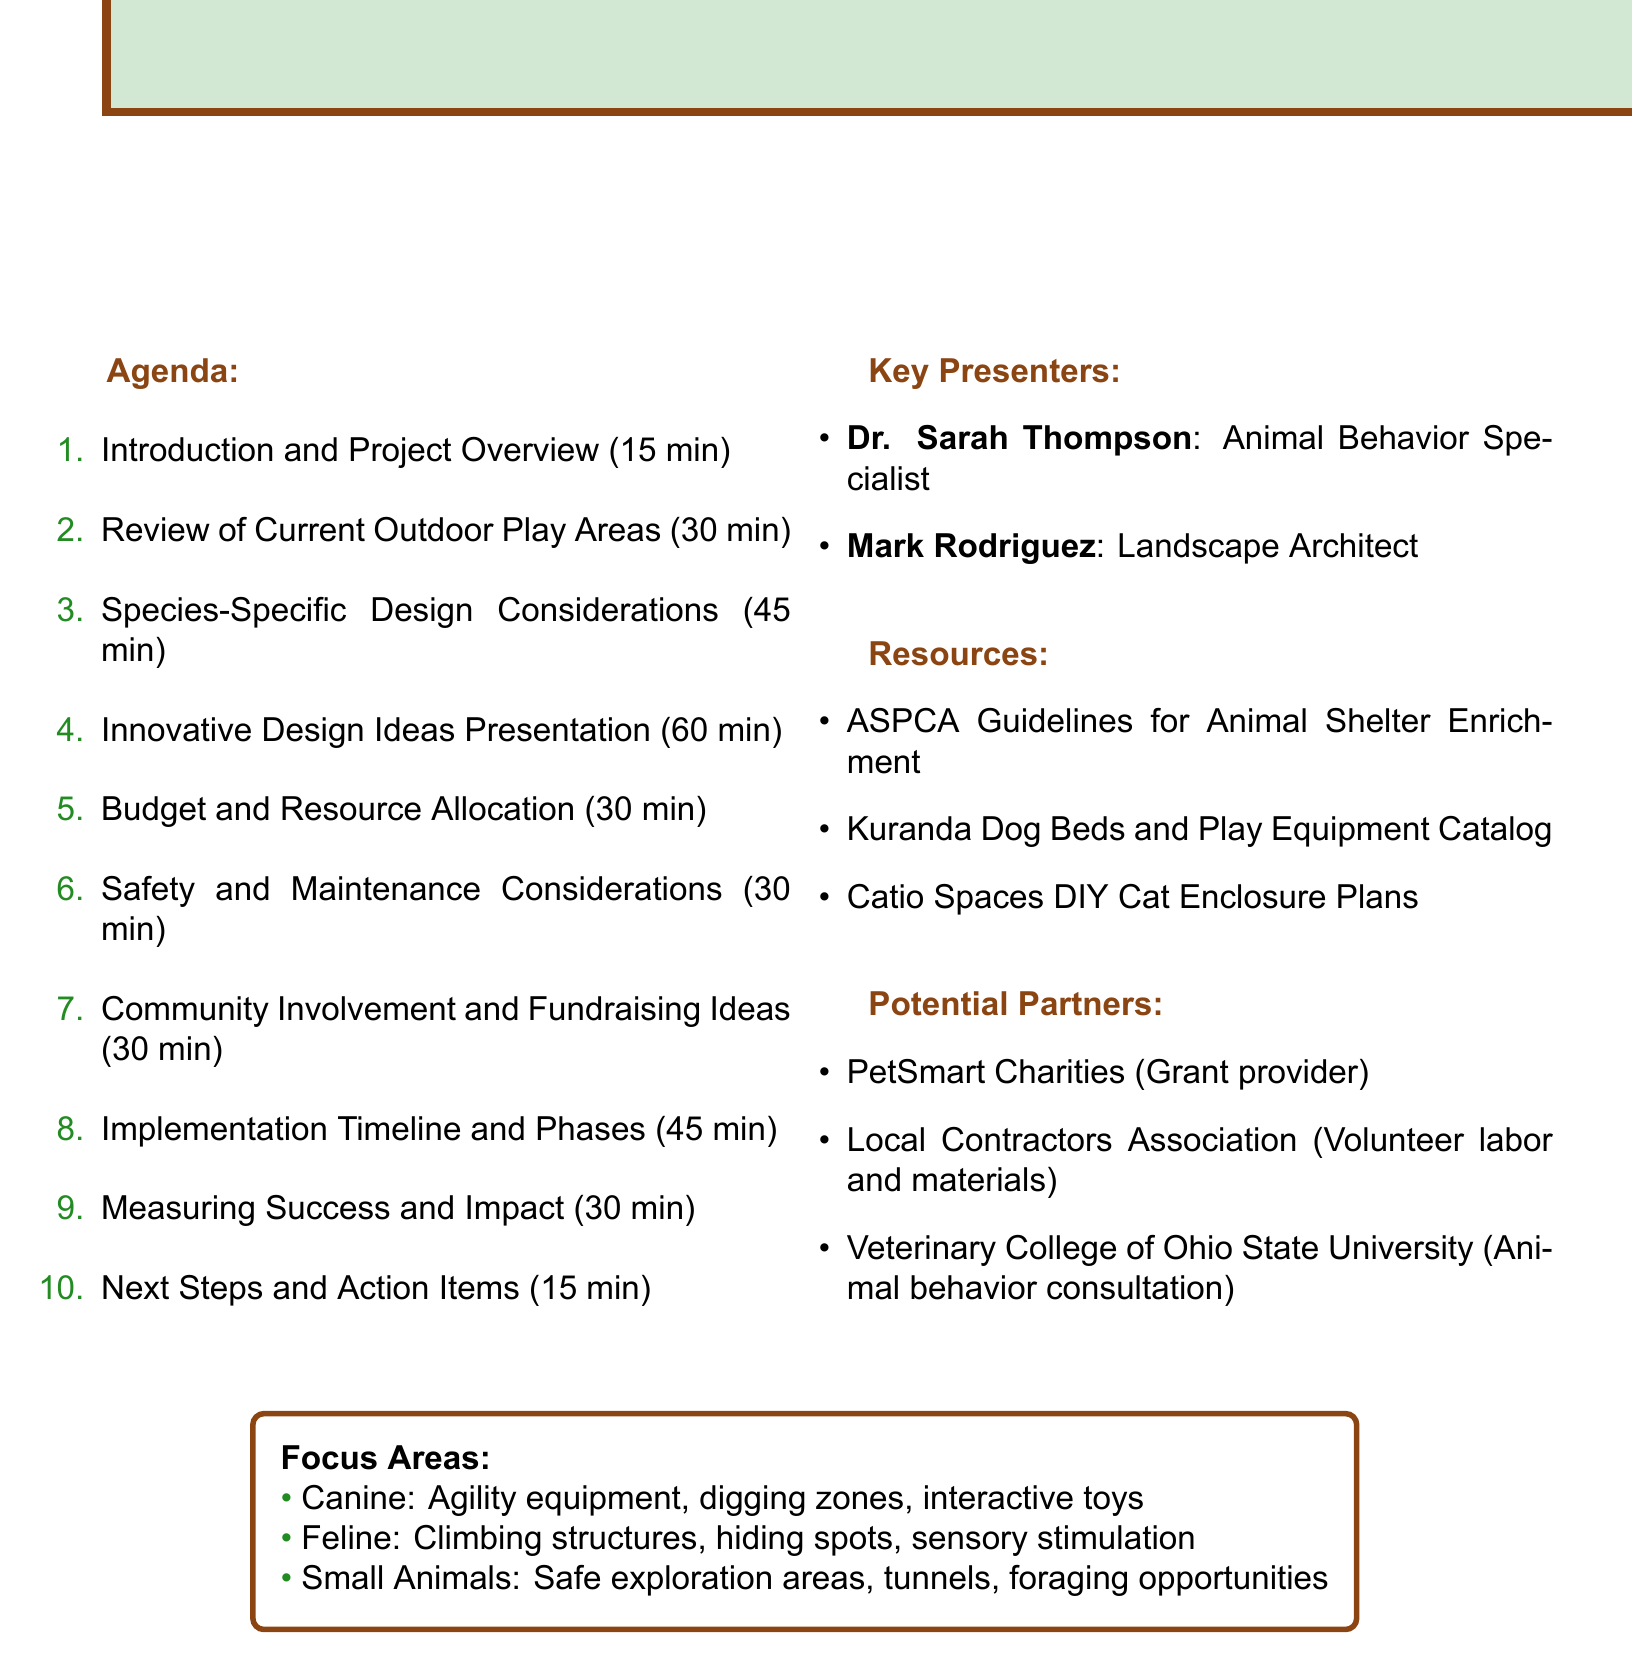What is the duration for the "Introduction and Project Overview" session? The document lists the duration for this session as 15 minutes.
Answer: 15 minutes Who is the presenter for "Cognitive enrichment through interactive play structures"? The document states that Dr. Sarah Thompson is the presenter for this topic.
Answer: Dr. Sarah Thompson What type of partner is the "Local Contractors Association"? The document specifies that this partner provides volunteer labor and materials.
Answer: Volunteer labor and materials How many minutes are allocated for the session on "Species-Specific Design Considerations"? The document shows that this session lasts for 45 minutes.
Answer: 45 minutes What are the key focus areas mentioned for small animals? The document lists safe exploration areas, tunnels, and foraging opportunities as key focus areas.
Answer: Safe exploration areas, tunnels, and foraging opportunities What is the main goal of the planning session as indicated in the introduction? The introduction emphasizes the importance of species-specific enrichment and well-being.
Answer: Species-specific enrichment and well-being What is the total duration of the "Innovative Design Ideas Presentation"? The document indicates that this presentation lasts for 60 minutes.
Answer: 60 minutes What type of resources are listed in the document? The document lists guidelines, catalogs, and DIY plans as the types of resources available.
Answer: Guidelines, catalogs, and DIY plans 